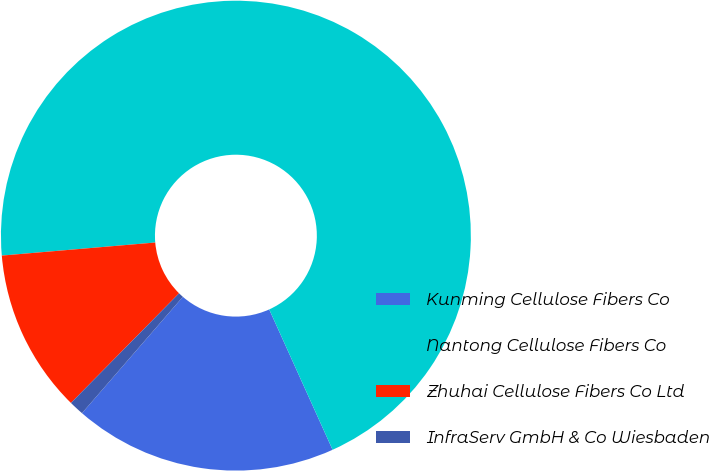Convert chart to OTSL. <chart><loc_0><loc_0><loc_500><loc_500><pie_chart><fcel>Kunming Cellulose Fibers Co<fcel>Nantong Cellulose Fibers Co<fcel>Zhuhai Cellulose Fibers Co Ltd<fcel>InfraServ GmbH & Co Wiesbaden<nl><fcel>18.12%<fcel>69.6%<fcel>11.26%<fcel>1.02%<nl></chart> 